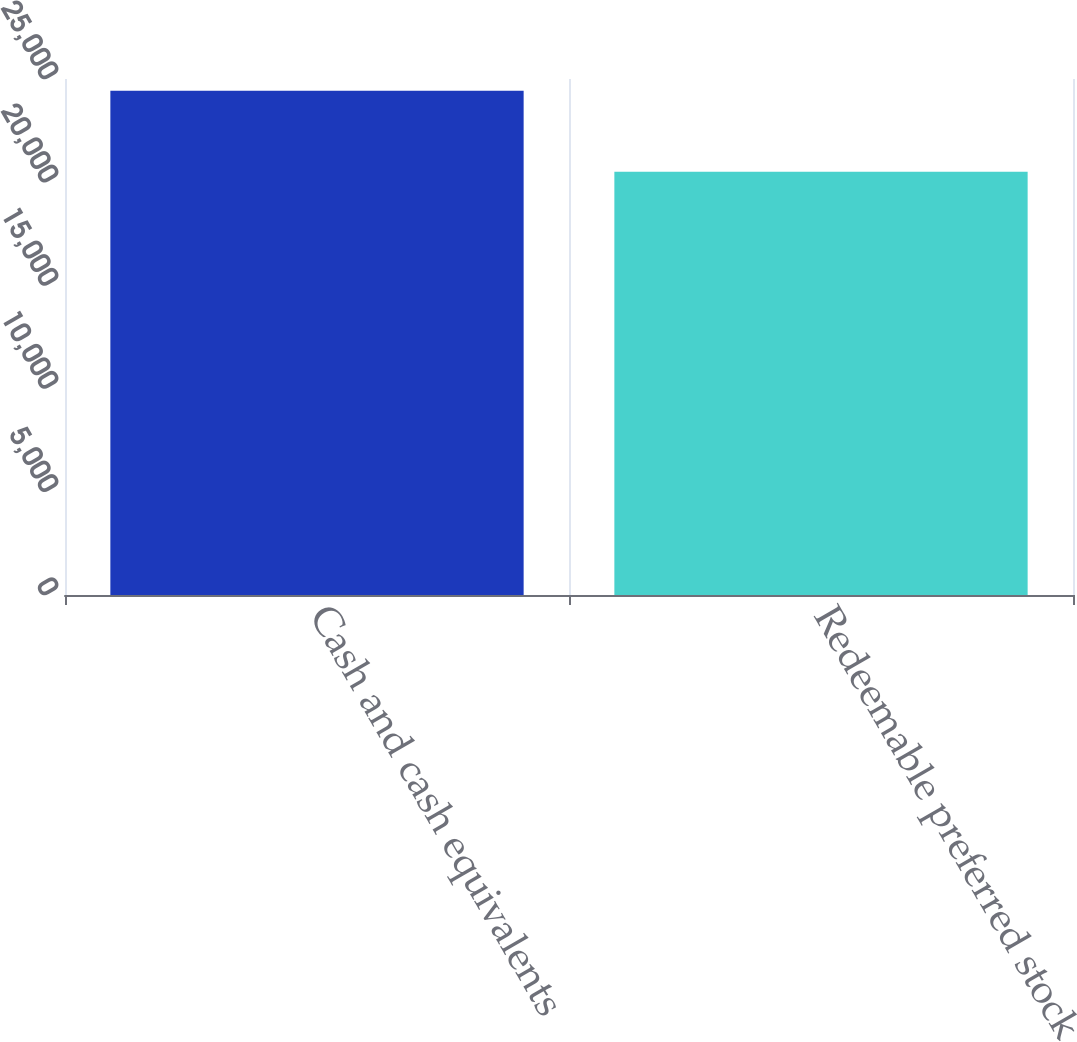Convert chart. <chart><loc_0><loc_0><loc_500><loc_500><bar_chart><fcel>Cash and cash equivalents<fcel>Redeemable preferred stock<nl><fcel>24433<fcel>20511<nl></chart> 